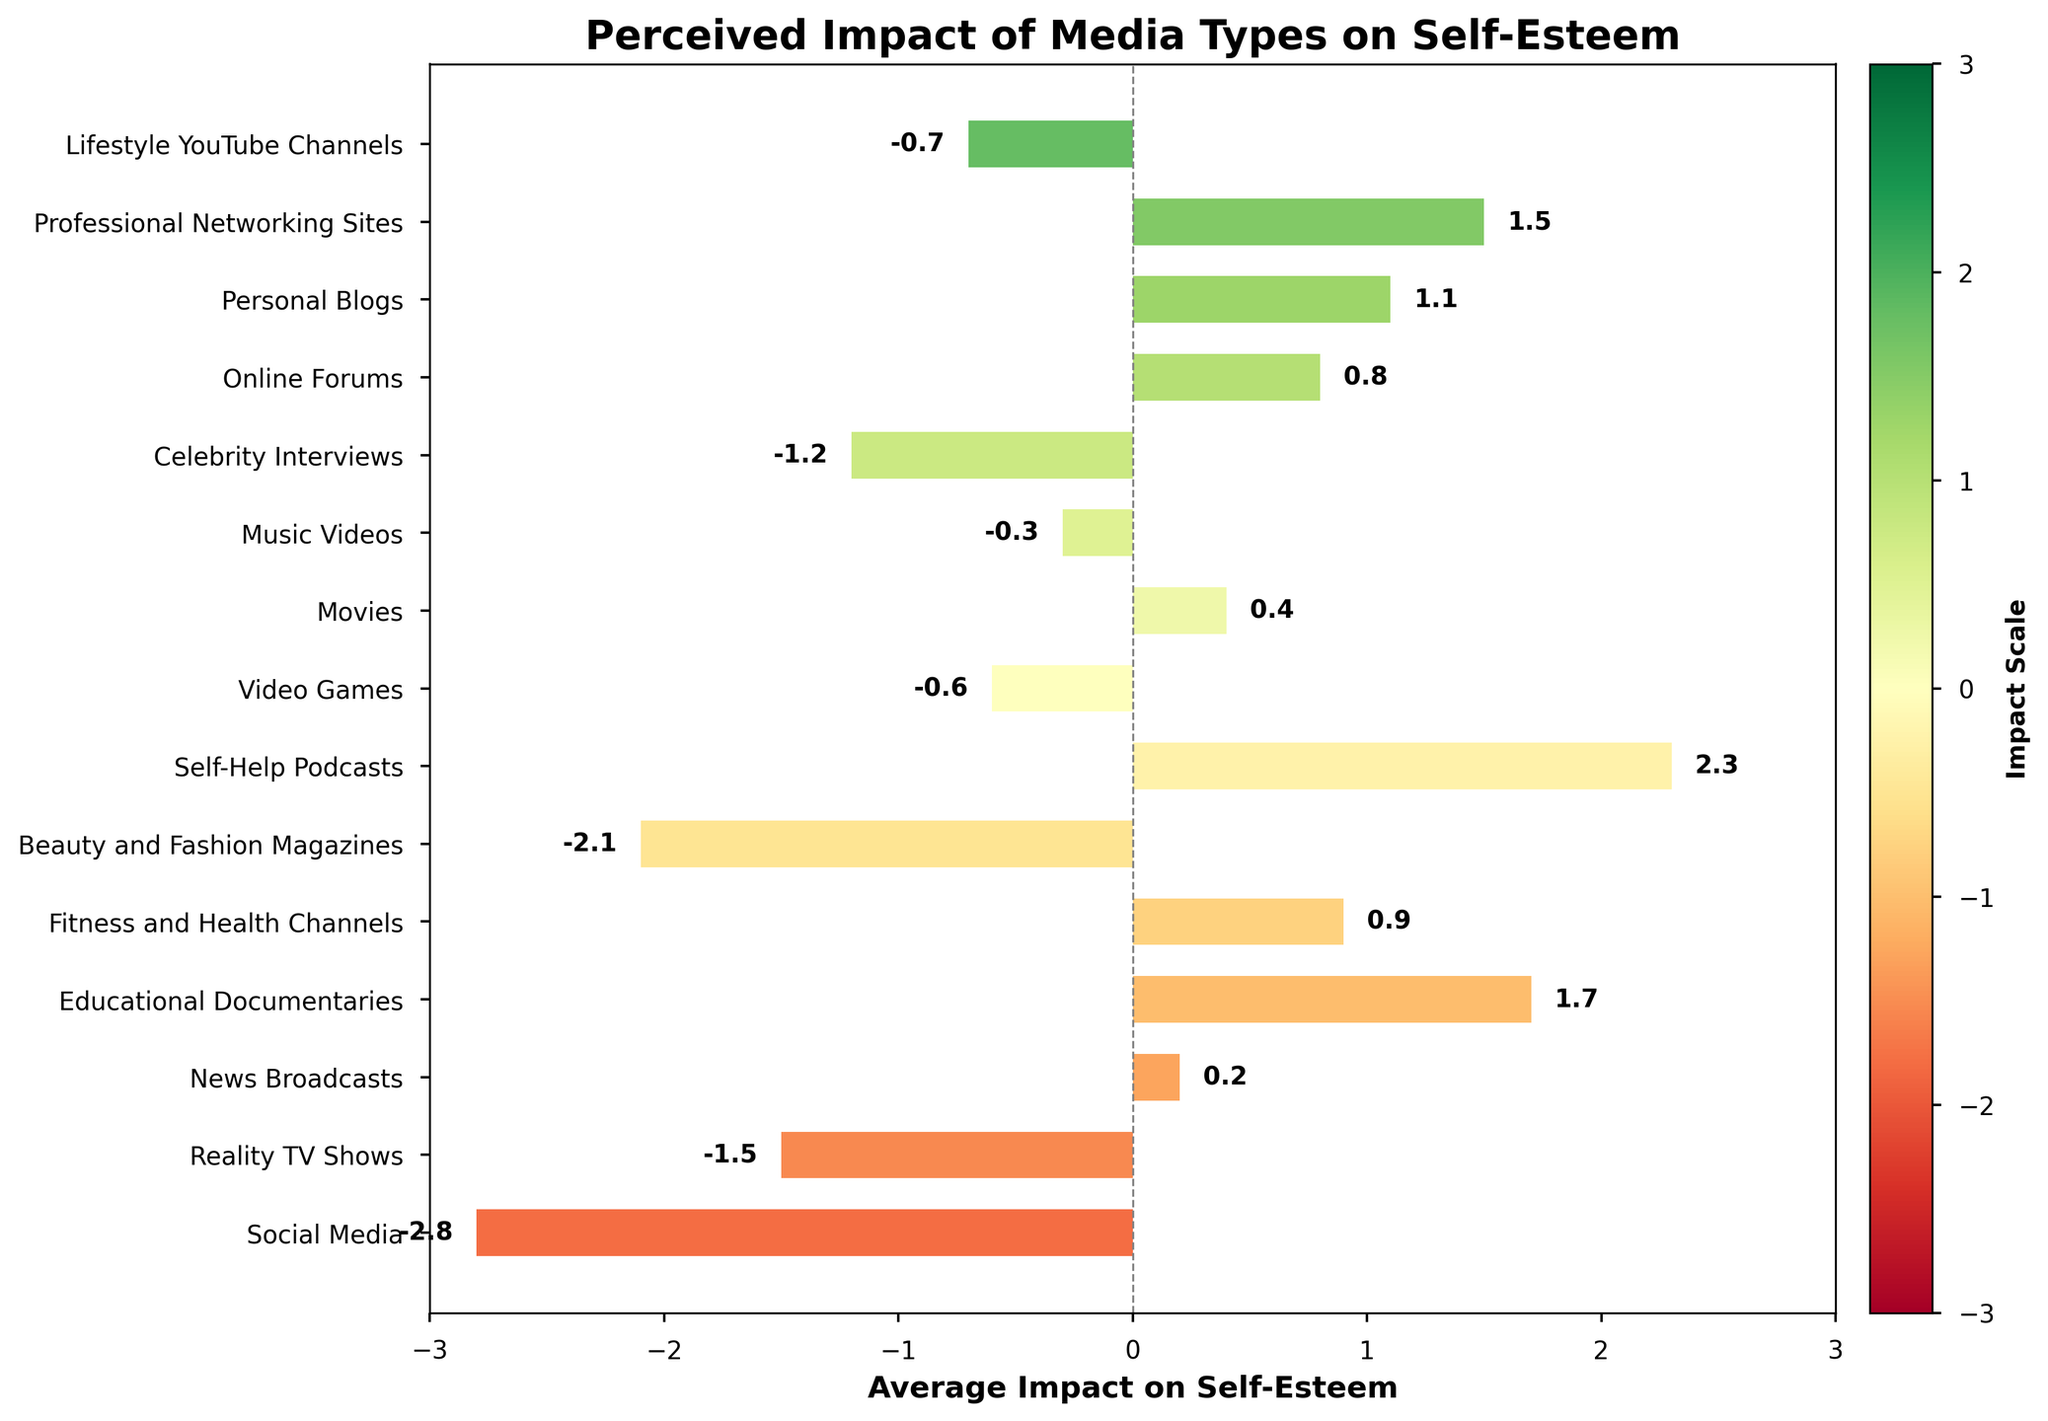What's the media type with the highest positive impact on self-esteem? From the figure, identify the bar with the highest average impact score. The bar representing "Self-Help Podcasts" reaches the highest point at 2.3.
Answer: Self-Help Podcasts Which two media types have an average impact of over 1.5 on self-esteem? Observe the bars that exceed the 1.5 mark on the average impact scale. "Self-Help Podcasts" (2.3) and "Educational Documentaries" (1.7) are above this threshold.
Answer: Self-Help Podcasts, Educational Documentaries Which media type has the lowest impact on self-esteem? Look for the bar with the lowest impact score. "Social Media" has the lowest impact score at -2.8.
Answer: Social Media How many media types have a positive impact on self-esteem? Count the number of bars with scores above 0. There are 7 bars with positive scores: News Broadcasts, Educational Documentaries, Fitness and Health Channels, Online Forums, Personal Blogs, Professional Networking Sites, Self-Help Podcasts.
Answer: 7 Compare the impact on self-esteem between Movies and Reality TV Shows. Which has a higher impact? Compare the positions of the bars for Movies and Reality TV Shows on the horizontal axis. Movies have a score of 0.4, which is higher than Reality TV Shows' score of -1.5.
Answer: Movies What's the average impact score for media types related to personal development (Self-Help Podcasts, Online Forums, Personal Blogs, Professional Networking Sites)? Add the scores and divide by the number of media types. (2.3 + 0.8 + 1.1 + 1.5)/4 = (5.7)/4 = 1.425.
Answer: 1.425 Which media types fall within the impact score range of -2.0 to -1.0? Identify bars with impact scores between -2.0 and -1.0. These include Beauty and Fashion Magazines (-2.1), Reality TV Shows (-1.5), and Celebrity Interviews (-1.2).
Answer: Reality TV Shows, Celebrity Interviews How many media types have a negative impact on self-esteem? Count the number of bars with scores below 0. There are 7 bars with negative scores.
Answer: 7 What is the difference in average impact on self-esteem between Social Media and Fitness and Health Channels? Subtract the impact score of Fitness and Health Channels from that of Social Media. -2.8 - 0.9 = -3.7.
Answer: -3.7 